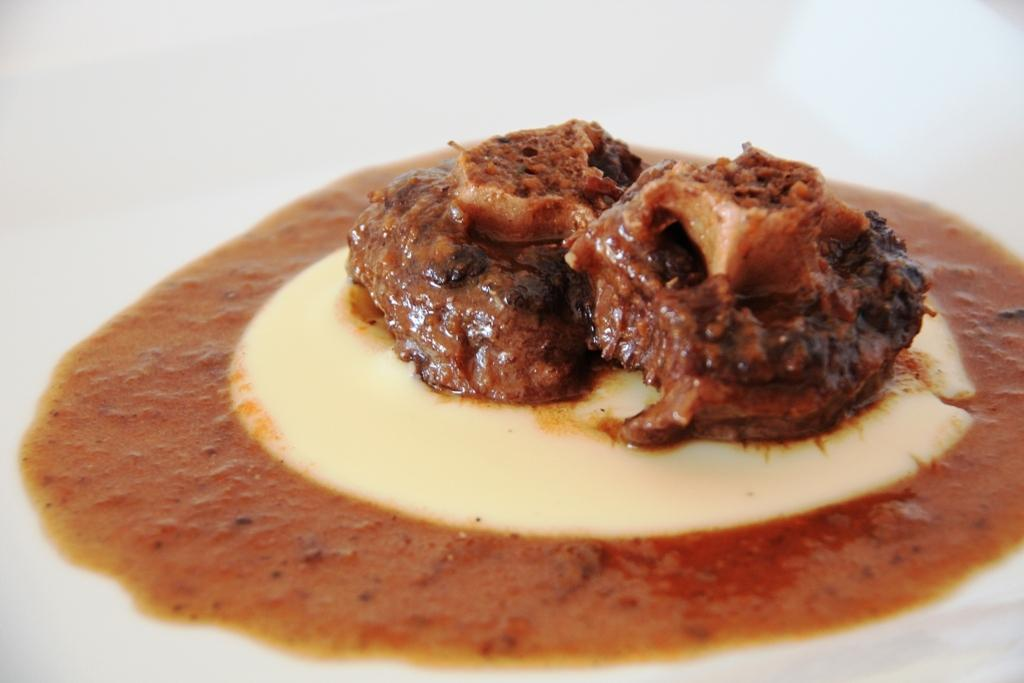What is the main subject of the image? There is a food item in the image. What type of stage is set up for the airplane in the image? There is no stage or airplane present in the image; it only features a food item. 